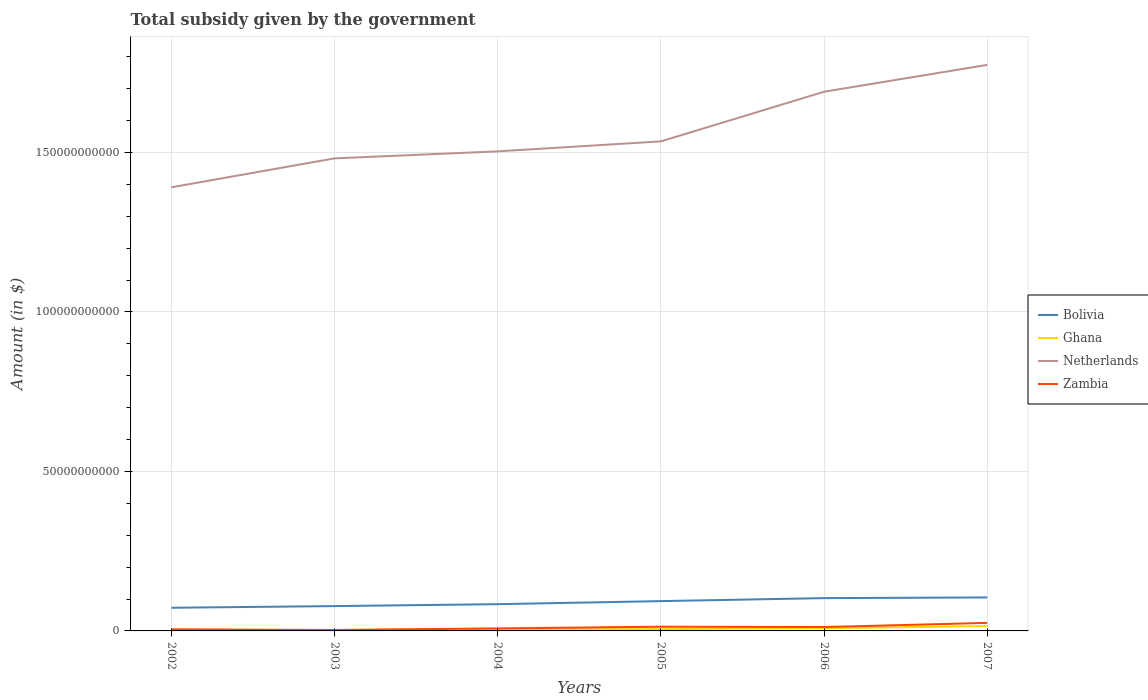Across all years, what is the maximum total revenue collected by the government in Zambia?
Offer a terse response. 2.97e+08. In which year was the total revenue collected by the government in Bolivia maximum?
Keep it short and to the point. 2002. What is the total total revenue collected by the government in Bolivia in the graph?
Provide a succinct answer. -3.02e+09. What is the difference between the highest and the second highest total revenue collected by the government in Netherlands?
Offer a very short reply. 3.84e+1. What is the difference between the highest and the lowest total revenue collected by the government in Ghana?
Ensure brevity in your answer.  2. What is the difference between two consecutive major ticks on the Y-axis?
Make the answer very short. 5.00e+1. Does the graph contain any zero values?
Your response must be concise. No. Where does the legend appear in the graph?
Provide a succinct answer. Center right. How many legend labels are there?
Your answer should be very brief. 4. How are the legend labels stacked?
Your answer should be very brief. Vertical. What is the title of the graph?
Provide a short and direct response. Total subsidy given by the government. What is the label or title of the X-axis?
Offer a terse response. Years. What is the label or title of the Y-axis?
Offer a very short reply. Amount (in $). What is the Amount (in $) of Bolivia in 2002?
Your answer should be compact. 7.27e+09. What is the Amount (in $) of Ghana in 2002?
Offer a terse response. 3.86e+07. What is the Amount (in $) of Netherlands in 2002?
Your answer should be very brief. 1.39e+11. What is the Amount (in $) in Zambia in 2002?
Your answer should be compact. 4.99e+08. What is the Amount (in $) of Bolivia in 2003?
Keep it short and to the point. 7.78e+09. What is the Amount (in $) of Ghana in 2003?
Give a very brief answer. 2.80e+08. What is the Amount (in $) of Netherlands in 2003?
Provide a short and direct response. 1.48e+11. What is the Amount (in $) of Zambia in 2003?
Make the answer very short. 2.97e+08. What is the Amount (in $) of Bolivia in 2004?
Provide a short and direct response. 8.39e+09. What is the Amount (in $) of Ghana in 2004?
Keep it short and to the point. 5.37e+08. What is the Amount (in $) of Netherlands in 2004?
Make the answer very short. 1.50e+11. What is the Amount (in $) of Zambia in 2004?
Your response must be concise. 7.88e+08. What is the Amount (in $) in Bolivia in 2005?
Ensure brevity in your answer.  9.35e+09. What is the Amount (in $) of Ghana in 2005?
Provide a succinct answer. 5.64e+08. What is the Amount (in $) in Netherlands in 2005?
Keep it short and to the point. 1.53e+11. What is the Amount (in $) in Zambia in 2005?
Keep it short and to the point. 1.32e+09. What is the Amount (in $) in Bolivia in 2006?
Provide a short and direct response. 1.03e+1. What is the Amount (in $) of Ghana in 2006?
Keep it short and to the point. 8.37e+08. What is the Amount (in $) of Netherlands in 2006?
Your response must be concise. 1.69e+11. What is the Amount (in $) in Zambia in 2006?
Your answer should be very brief. 1.21e+09. What is the Amount (in $) of Bolivia in 2007?
Provide a short and direct response. 1.05e+1. What is the Amount (in $) of Ghana in 2007?
Give a very brief answer. 1.53e+09. What is the Amount (in $) of Netherlands in 2007?
Your answer should be compact. 1.77e+11. What is the Amount (in $) of Zambia in 2007?
Your response must be concise. 2.52e+09. Across all years, what is the maximum Amount (in $) in Bolivia?
Keep it short and to the point. 1.05e+1. Across all years, what is the maximum Amount (in $) of Ghana?
Provide a short and direct response. 1.53e+09. Across all years, what is the maximum Amount (in $) of Netherlands?
Give a very brief answer. 1.77e+11. Across all years, what is the maximum Amount (in $) in Zambia?
Offer a terse response. 2.52e+09. Across all years, what is the minimum Amount (in $) in Bolivia?
Offer a very short reply. 7.27e+09. Across all years, what is the minimum Amount (in $) in Ghana?
Make the answer very short. 3.86e+07. Across all years, what is the minimum Amount (in $) in Netherlands?
Make the answer very short. 1.39e+11. Across all years, what is the minimum Amount (in $) in Zambia?
Ensure brevity in your answer.  2.97e+08. What is the total Amount (in $) in Bolivia in the graph?
Your answer should be compact. 5.36e+1. What is the total Amount (in $) in Ghana in the graph?
Your answer should be compact. 3.78e+09. What is the total Amount (in $) of Netherlands in the graph?
Ensure brevity in your answer.  9.37e+11. What is the total Amount (in $) in Zambia in the graph?
Make the answer very short. 6.64e+09. What is the difference between the Amount (in $) of Bolivia in 2002 and that in 2003?
Your answer should be very brief. -5.16e+08. What is the difference between the Amount (in $) of Ghana in 2002 and that in 2003?
Keep it short and to the point. -2.42e+08. What is the difference between the Amount (in $) in Netherlands in 2002 and that in 2003?
Offer a very short reply. -9.08e+09. What is the difference between the Amount (in $) in Zambia in 2002 and that in 2003?
Give a very brief answer. 2.02e+08. What is the difference between the Amount (in $) of Bolivia in 2002 and that in 2004?
Your answer should be compact. -1.12e+09. What is the difference between the Amount (in $) of Ghana in 2002 and that in 2004?
Provide a succinct answer. -4.98e+08. What is the difference between the Amount (in $) of Netherlands in 2002 and that in 2004?
Offer a very short reply. -1.13e+1. What is the difference between the Amount (in $) of Zambia in 2002 and that in 2004?
Provide a succinct answer. -2.89e+08. What is the difference between the Amount (in $) of Bolivia in 2002 and that in 2005?
Ensure brevity in your answer.  -2.08e+09. What is the difference between the Amount (in $) of Ghana in 2002 and that in 2005?
Provide a short and direct response. -5.25e+08. What is the difference between the Amount (in $) in Netherlands in 2002 and that in 2005?
Your response must be concise. -1.44e+1. What is the difference between the Amount (in $) of Zambia in 2002 and that in 2005?
Offer a very short reply. -8.23e+08. What is the difference between the Amount (in $) of Bolivia in 2002 and that in 2006?
Ensure brevity in your answer.  -3.02e+09. What is the difference between the Amount (in $) of Ghana in 2002 and that in 2006?
Provide a short and direct response. -7.98e+08. What is the difference between the Amount (in $) of Netherlands in 2002 and that in 2006?
Give a very brief answer. -3.00e+1. What is the difference between the Amount (in $) of Zambia in 2002 and that in 2006?
Provide a succinct answer. -7.11e+08. What is the difference between the Amount (in $) of Bolivia in 2002 and that in 2007?
Your answer should be compact. -3.23e+09. What is the difference between the Amount (in $) in Ghana in 2002 and that in 2007?
Offer a very short reply. -1.49e+09. What is the difference between the Amount (in $) of Netherlands in 2002 and that in 2007?
Give a very brief answer. -3.84e+1. What is the difference between the Amount (in $) in Zambia in 2002 and that in 2007?
Give a very brief answer. -2.02e+09. What is the difference between the Amount (in $) in Bolivia in 2003 and that in 2004?
Give a very brief answer. -6.06e+08. What is the difference between the Amount (in $) in Ghana in 2003 and that in 2004?
Provide a succinct answer. -2.57e+08. What is the difference between the Amount (in $) of Netherlands in 2003 and that in 2004?
Your answer should be compact. -2.20e+09. What is the difference between the Amount (in $) of Zambia in 2003 and that in 2004?
Give a very brief answer. -4.91e+08. What is the difference between the Amount (in $) in Bolivia in 2003 and that in 2005?
Give a very brief answer. -1.56e+09. What is the difference between the Amount (in $) of Ghana in 2003 and that in 2005?
Make the answer very short. -2.84e+08. What is the difference between the Amount (in $) in Netherlands in 2003 and that in 2005?
Make the answer very short. -5.32e+09. What is the difference between the Amount (in $) in Zambia in 2003 and that in 2005?
Offer a very short reply. -1.02e+09. What is the difference between the Amount (in $) of Bolivia in 2003 and that in 2006?
Your response must be concise. -2.50e+09. What is the difference between the Amount (in $) of Ghana in 2003 and that in 2006?
Keep it short and to the point. -5.57e+08. What is the difference between the Amount (in $) of Netherlands in 2003 and that in 2006?
Keep it short and to the point. -2.09e+1. What is the difference between the Amount (in $) in Zambia in 2003 and that in 2006?
Your response must be concise. -9.13e+08. What is the difference between the Amount (in $) of Bolivia in 2003 and that in 2007?
Provide a succinct answer. -2.71e+09. What is the difference between the Amount (in $) in Ghana in 2003 and that in 2007?
Ensure brevity in your answer.  -1.25e+09. What is the difference between the Amount (in $) in Netherlands in 2003 and that in 2007?
Provide a short and direct response. -2.93e+1. What is the difference between the Amount (in $) of Zambia in 2003 and that in 2007?
Your answer should be very brief. -2.23e+09. What is the difference between the Amount (in $) in Bolivia in 2004 and that in 2005?
Offer a very short reply. -9.58e+08. What is the difference between the Amount (in $) of Ghana in 2004 and that in 2005?
Ensure brevity in your answer.  -2.71e+07. What is the difference between the Amount (in $) in Netherlands in 2004 and that in 2005?
Your answer should be compact. -3.13e+09. What is the difference between the Amount (in $) of Zambia in 2004 and that in 2005?
Make the answer very short. -5.34e+08. What is the difference between the Amount (in $) of Bolivia in 2004 and that in 2006?
Make the answer very short. -1.90e+09. What is the difference between the Amount (in $) of Ghana in 2004 and that in 2006?
Ensure brevity in your answer.  -3.00e+08. What is the difference between the Amount (in $) of Netherlands in 2004 and that in 2006?
Keep it short and to the point. -1.87e+1. What is the difference between the Amount (in $) of Zambia in 2004 and that in 2006?
Offer a terse response. -4.23e+08. What is the difference between the Amount (in $) in Bolivia in 2004 and that in 2007?
Your response must be concise. -2.11e+09. What is the difference between the Amount (in $) of Ghana in 2004 and that in 2007?
Provide a succinct answer. -9.92e+08. What is the difference between the Amount (in $) in Netherlands in 2004 and that in 2007?
Offer a terse response. -2.71e+1. What is the difference between the Amount (in $) in Zambia in 2004 and that in 2007?
Your response must be concise. -1.73e+09. What is the difference between the Amount (in $) in Bolivia in 2005 and that in 2006?
Your answer should be compact. -9.38e+08. What is the difference between the Amount (in $) in Ghana in 2005 and that in 2006?
Provide a succinct answer. -2.73e+08. What is the difference between the Amount (in $) in Netherlands in 2005 and that in 2006?
Offer a terse response. -1.56e+1. What is the difference between the Amount (in $) of Zambia in 2005 and that in 2006?
Your answer should be compact. 1.12e+08. What is the difference between the Amount (in $) of Bolivia in 2005 and that in 2007?
Offer a very short reply. -1.15e+09. What is the difference between the Amount (in $) of Ghana in 2005 and that in 2007?
Give a very brief answer. -9.65e+08. What is the difference between the Amount (in $) in Netherlands in 2005 and that in 2007?
Ensure brevity in your answer.  -2.40e+1. What is the difference between the Amount (in $) of Zambia in 2005 and that in 2007?
Provide a succinct answer. -1.20e+09. What is the difference between the Amount (in $) in Bolivia in 2006 and that in 2007?
Provide a short and direct response. -2.12e+08. What is the difference between the Amount (in $) of Ghana in 2006 and that in 2007?
Provide a short and direct response. -6.92e+08. What is the difference between the Amount (in $) in Netherlands in 2006 and that in 2007?
Keep it short and to the point. -8.42e+09. What is the difference between the Amount (in $) in Zambia in 2006 and that in 2007?
Your answer should be compact. -1.31e+09. What is the difference between the Amount (in $) in Bolivia in 2002 and the Amount (in $) in Ghana in 2003?
Offer a terse response. 6.99e+09. What is the difference between the Amount (in $) in Bolivia in 2002 and the Amount (in $) in Netherlands in 2003?
Offer a very short reply. -1.41e+11. What is the difference between the Amount (in $) of Bolivia in 2002 and the Amount (in $) of Zambia in 2003?
Give a very brief answer. 6.97e+09. What is the difference between the Amount (in $) in Ghana in 2002 and the Amount (in $) in Netherlands in 2003?
Ensure brevity in your answer.  -1.48e+11. What is the difference between the Amount (in $) of Ghana in 2002 and the Amount (in $) of Zambia in 2003?
Your response must be concise. -2.59e+08. What is the difference between the Amount (in $) in Netherlands in 2002 and the Amount (in $) in Zambia in 2003?
Your response must be concise. 1.39e+11. What is the difference between the Amount (in $) in Bolivia in 2002 and the Amount (in $) in Ghana in 2004?
Your answer should be compact. 6.73e+09. What is the difference between the Amount (in $) of Bolivia in 2002 and the Amount (in $) of Netherlands in 2004?
Keep it short and to the point. -1.43e+11. What is the difference between the Amount (in $) of Bolivia in 2002 and the Amount (in $) of Zambia in 2004?
Keep it short and to the point. 6.48e+09. What is the difference between the Amount (in $) of Ghana in 2002 and the Amount (in $) of Netherlands in 2004?
Offer a terse response. -1.50e+11. What is the difference between the Amount (in $) in Ghana in 2002 and the Amount (in $) in Zambia in 2004?
Your answer should be compact. -7.49e+08. What is the difference between the Amount (in $) of Netherlands in 2002 and the Amount (in $) of Zambia in 2004?
Keep it short and to the point. 1.38e+11. What is the difference between the Amount (in $) of Bolivia in 2002 and the Amount (in $) of Ghana in 2005?
Offer a very short reply. 6.70e+09. What is the difference between the Amount (in $) in Bolivia in 2002 and the Amount (in $) in Netherlands in 2005?
Give a very brief answer. -1.46e+11. What is the difference between the Amount (in $) in Bolivia in 2002 and the Amount (in $) in Zambia in 2005?
Provide a succinct answer. 5.94e+09. What is the difference between the Amount (in $) in Ghana in 2002 and the Amount (in $) in Netherlands in 2005?
Make the answer very short. -1.53e+11. What is the difference between the Amount (in $) in Ghana in 2002 and the Amount (in $) in Zambia in 2005?
Make the answer very short. -1.28e+09. What is the difference between the Amount (in $) in Netherlands in 2002 and the Amount (in $) in Zambia in 2005?
Make the answer very short. 1.38e+11. What is the difference between the Amount (in $) of Bolivia in 2002 and the Amount (in $) of Ghana in 2006?
Offer a very short reply. 6.43e+09. What is the difference between the Amount (in $) in Bolivia in 2002 and the Amount (in $) in Netherlands in 2006?
Offer a very short reply. -1.62e+11. What is the difference between the Amount (in $) of Bolivia in 2002 and the Amount (in $) of Zambia in 2006?
Offer a very short reply. 6.06e+09. What is the difference between the Amount (in $) in Ghana in 2002 and the Amount (in $) in Netherlands in 2006?
Offer a terse response. -1.69e+11. What is the difference between the Amount (in $) of Ghana in 2002 and the Amount (in $) of Zambia in 2006?
Ensure brevity in your answer.  -1.17e+09. What is the difference between the Amount (in $) of Netherlands in 2002 and the Amount (in $) of Zambia in 2006?
Offer a terse response. 1.38e+11. What is the difference between the Amount (in $) in Bolivia in 2002 and the Amount (in $) in Ghana in 2007?
Your answer should be very brief. 5.74e+09. What is the difference between the Amount (in $) of Bolivia in 2002 and the Amount (in $) of Netherlands in 2007?
Give a very brief answer. -1.70e+11. What is the difference between the Amount (in $) of Bolivia in 2002 and the Amount (in $) of Zambia in 2007?
Ensure brevity in your answer.  4.74e+09. What is the difference between the Amount (in $) of Ghana in 2002 and the Amount (in $) of Netherlands in 2007?
Provide a succinct answer. -1.77e+11. What is the difference between the Amount (in $) of Ghana in 2002 and the Amount (in $) of Zambia in 2007?
Your answer should be very brief. -2.48e+09. What is the difference between the Amount (in $) of Netherlands in 2002 and the Amount (in $) of Zambia in 2007?
Provide a succinct answer. 1.37e+11. What is the difference between the Amount (in $) in Bolivia in 2003 and the Amount (in $) in Ghana in 2004?
Offer a very short reply. 7.24e+09. What is the difference between the Amount (in $) in Bolivia in 2003 and the Amount (in $) in Netherlands in 2004?
Your answer should be compact. -1.43e+11. What is the difference between the Amount (in $) in Bolivia in 2003 and the Amount (in $) in Zambia in 2004?
Provide a short and direct response. 6.99e+09. What is the difference between the Amount (in $) in Ghana in 2003 and the Amount (in $) in Netherlands in 2004?
Your answer should be compact. -1.50e+11. What is the difference between the Amount (in $) of Ghana in 2003 and the Amount (in $) of Zambia in 2004?
Give a very brief answer. -5.08e+08. What is the difference between the Amount (in $) of Netherlands in 2003 and the Amount (in $) of Zambia in 2004?
Your response must be concise. 1.47e+11. What is the difference between the Amount (in $) in Bolivia in 2003 and the Amount (in $) in Ghana in 2005?
Your answer should be very brief. 7.22e+09. What is the difference between the Amount (in $) in Bolivia in 2003 and the Amount (in $) in Netherlands in 2005?
Make the answer very short. -1.46e+11. What is the difference between the Amount (in $) in Bolivia in 2003 and the Amount (in $) in Zambia in 2005?
Give a very brief answer. 6.46e+09. What is the difference between the Amount (in $) of Ghana in 2003 and the Amount (in $) of Netherlands in 2005?
Provide a short and direct response. -1.53e+11. What is the difference between the Amount (in $) of Ghana in 2003 and the Amount (in $) of Zambia in 2005?
Your answer should be compact. -1.04e+09. What is the difference between the Amount (in $) in Netherlands in 2003 and the Amount (in $) in Zambia in 2005?
Your response must be concise. 1.47e+11. What is the difference between the Amount (in $) in Bolivia in 2003 and the Amount (in $) in Ghana in 2006?
Keep it short and to the point. 6.94e+09. What is the difference between the Amount (in $) of Bolivia in 2003 and the Amount (in $) of Netherlands in 2006?
Offer a terse response. -1.61e+11. What is the difference between the Amount (in $) of Bolivia in 2003 and the Amount (in $) of Zambia in 2006?
Provide a succinct answer. 6.57e+09. What is the difference between the Amount (in $) of Ghana in 2003 and the Amount (in $) of Netherlands in 2006?
Keep it short and to the point. -1.69e+11. What is the difference between the Amount (in $) of Ghana in 2003 and the Amount (in $) of Zambia in 2006?
Give a very brief answer. -9.31e+08. What is the difference between the Amount (in $) of Netherlands in 2003 and the Amount (in $) of Zambia in 2006?
Provide a short and direct response. 1.47e+11. What is the difference between the Amount (in $) in Bolivia in 2003 and the Amount (in $) in Ghana in 2007?
Ensure brevity in your answer.  6.25e+09. What is the difference between the Amount (in $) of Bolivia in 2003 and the Amount (in $) of Netherlands in 2007?
Your response must be concise. -1.70e+11. What is the difference between the Amount (in $) in Bolivia in 2003 and the Amount (in $) in Zambia in 2007?
Ensure brevity in your answer.  5.26e+09. What is the difference between the Amount (in $) of Ghana in 2003 and the Amount (in $) of Netherlands in 2007?
Make the answer very short. -1.77e+11. What is the difference between the Amount (in $) in Ghana in 2003 and the Amount (in $) in Zambia in 2007?
Your response must be concise. -2.24e+09. What is the difference between the Amount (in $) in Netherlands in 2003 and the Amount (in $) in Zambia in 2007?
Your response must be concise. 1.46e+11. What is the difference between the Amount (in $) of Bolivia in 2004 and the Amount (in $) of Ghana in 2005?
Provide a succinct answer. 7.82e+09. What is the difference between the Amount (in $) of Bolivia in 2004 and the Amount (in $) of Netherlands in 2005?
Your answer should be compact. -1.45e+11. What is the difference between the Amount (in $) of Bolivia in 2004 and the Amount (in $) of Zambia in 2005?
Your answer should be very brief. 7.07e+09. What is the difference between the Amount (in $) of Ghana in 2004 and the Amount (in $) of Netherlands in 2005?
Provide a short and direct response. -1.53e+11. What is the difference between the Amount (in $) of Ghana in 2004 and the Amount (in $) of Zambia in 2005?
Ensure brevity in your answer.  -7.85e+08. What is the difference between the Amount (in $) of Netherlands in 2004 and the Amount (in $) of Zambia in 2005?
Provide a short and direct response. 1.49e+11. What is the difference between the Amount (in $) in Bolivia in 2004 and the Amount (in $) in Ghana in 2006?
Your answer should be very brief. 7.55e+09. What is the difference between the Amount (in $) of Bolivia in 2004 and the Amount (in $) of Netherlands in 2006?
Your answer should be compact. -1.61e+11. What is the difference between the Amount (in $) of Bolivia in 2004 and the Amount (in $) of Zambia in 2006?
Offer a terse response. 7.18e+09. What is the difference between the Amount (in $) of Ghana in 2004 and the Amount (in $) of Netherlands in 2006?
Keep it short and to the point. -1.68e+11. What is the difference between the Amount (in $) in Ghana in 2004 and the Amount (in $) in Zambia in 2006?
Provide a succinct answer. -6.74e+08. What is the difference between the Amount (in $) in Netherlands in 2004 and the Amount (in $) in Zambia in 2006?
Give a very brief answer. 1.49e+11. What is the difference between the Amount (in $) of Bolivia in 2004 and the Amount (in $) of Ghana in 2007?
Ensure brevity in your answer.  6.86e+09. What is the difference between the Amount (in $) in Bolivia in 2004 and the Amount (in $) in Netherlands in 2007?
Provide a succinct answer. -1.69e+11. What is the difference between the Amount (in $) in Bolivia in 2004 and the Amount (in $) in Zambia in 2007?
Offer a very short reply. 5.86e+09. What is the difference between the Amount (in $) in Ghana in 2004 and the Amount (in $) in Netherlands in 2007?
Provide a short and direct response. -1.77e+11. What is the difference between the Amount (in $) of Ghana in 2004 and the Amount (in $) of Zambia in 2007?
Offer a terse response. -1.99e+09. What is the difference between the Amount (in $) in Netherlands in 2004 and the Amount (in $) in Zambia in 2007?
Give a very brief answer. 1.48e+11. What is the difference between the Amount (in $) of Bolivia in 2005 and the Amount (in $) of Ghana in 2006?
Keep it short and to the point. 8.51e+09. What is the difference between the Amount (in $) in Bolivia in 2005 and the Amount (in $) in Netherlands in 2006?
Make the answer very short. -1.60e+11. What is the difference between the Amount (in $) in Bolivia in 2005 and the Amount (in $) in Zambia in 2006?
Your response must be concise. 8.13e+09. What is the difference between the Amount (in $) of Ghana in 2005 and the Amount (in $) of Netherlands in 2006?
Keep it short and to the point. -1.68e+11. What is the difference between the Amount (in $) of Ghana in 2005 and the Amount (in $) of Zambia in 2006?
Provide a succinct answer. -6.47e+08. What is the difference between the Amount (in $) in Netherlands in 2005 and the Amount (in $) in Zambia in 2006?
Provide a succinct answer. 1.52e+11. What is the difference between the Amount (in $) of Bolivia in 2005 and the Amount (in $) of Ghana in 2007?
Give a very brief answer. 7.82e+09. What is the difference between the Amount (in $) of Bolivia in 2005 and the Amount (in $) of Netherlands in 2007?
Keep it short and to the point. -1.68e+11. What is the difference between the Amount (in $) in Bolivia in 2005 and the Amount (in $) in Zambia in 2007?
Ensure brevity in your answer.  6.82e+09. What is the difference between the Amount (in $) in Ghana in 2005 and the Amount (in $) in Netherlands in 2007?
Your response must be concise. -1.77e+11. What is the difference between the Amount (in $) in Ghana in 2005 and the Amount (in $) in Zambia in 2007?
Make the answer very short. -1.96e+09. What is the difference between the Amount (in $) of Netherlands in 2005 and the Amount (in $) of Zambia in 2007?
Offer a terse response. 1.51e+11. What is the difference between the Amount (in $) of Bolivia in 2006 and the Amount (in $) of Ghana in 2007?
Give a very brief answer. 8.75e+09. What is the difference between the Amount (in $) of Bolivia in 2006 and the Amount (in $) of Netherlands in 2007?
Ensure brevity in your answer.  -1.67e+11. What is the difference between the Amount (in $) of Bolivia in 2006 and the Amount (in $) of Zambia in 2007?
Make the answer very short. 7.76e+09. What is the difference between the Amount (in $) in Ghana in 2006 and the Amount (in $) in Netherlands in 2007?
Your answer should be compact. -1.77e+11. What is the difference between the Amount (in $) in Ghana in 2006 and the Amount (in $) in Zambia in 2007?
Keep it short and to the point. -1.69e+09. What is the difference between the Amount (in $) of Netherlands in 2006 and the Amount (in $) of Zambia in 2007?
Provide a short and direct response. 1.67e+11. What is the average Amount (in $) of Bolivia per year?
Keep it short and to the point. 8.93e+09. What is the average Amount (in $) of Ghana per year?
Offer a terse response. 6.31e+08. What is the average Amount (in $) of Netherlands per year?
Provide a succinct answer. 1.56e+11. What is the average Amount (in $) of Zambia per year?
Offer a terse response. 1.11e+09. In the year 2002, what is the difference between the Amount (in $) of Bolivia and Amount (in $) of Ghana?
Offer a very short reply. 7.23e+09. In the year 2002, what is the difference between the Amount (in $) of Bolivia and Amount (in $) of Netherlands?
Offer a very short reply. -1.32e+11. In the year 2002, what is the difference between the Amount (in $) in Bolivia and Amount (in $) in Zambia?
Make the answer very short. 6.77e+09. In the year 2002, what is the difference between the Amount (in $) in Ghana and Amount (in $) in Netherlands?
Your answer should be very brief. -1.39e+11. In the year 2002, what is the difference between the Amount (in $) in Ghana and Amount (in $) in Zambia?
Your response must be concise. -4.61e+08. In the year 2002, what is the difference between the Amount (in $) in Netherlands and Amount (in $) in Zambia?
Make the answer very short. 1.39e+11. In the year 2003, what is the difference between the Amount (in $) in Bolivia and Amount (in $) in Ghana?
Keep it short and to the point. 7.50e+09. In the year 2003, what is the difference between the Amount (in $) in Bolivia and Amount (in $) in Netherlands?
Provide a short and direct response. -1.40e+11. In the year 2003, what is the difference between the Amount (in $) in Bolivia and Amount (in $) in Zambia?
Provide a succinct answer. 7.48e+09. In the year 2003, what is the difference between the Amount (in $) in Ghana and Amount (in $) in Netherlands?
Ensure brevity in your answer.  -1.48e+11. In the year 2003, what is the difference between the Amount (in $) of Ghana and Amount (in $) of Zambia?
Ensure brevity in your answer.  -1.72e+07. In the year 2003, what is the difference between the Amount (in $) in Netherlands and Amount (in $) in Zambia?
Offer a very short reply. 1.48e+11. In the year 2004, what is the difference between the Amount (in $) in Bolivia and Amount (in $) in Ghana?
Give a very brief answer. 7.85e+09. In the year 2004, what is the difference between the Amount (in $) in Bolivia and Amount (in $) in Netherlands?
Provide a succinct answer. -1.42e+11. In the year 2004, what is the difference between the Amount (in $) of Bolivia and Amount (in $) of Zambia?
Your answer should be compact. 7.60e+09. In the year 2004, what is the difference between the Amount (in $) in Ghana and Amount (in $) in Netherlands?
Your answer should be compact. -1.50e+11. In the year 2004, what is the difference between the Amount (in $) in Ghana and Amount (in $) in Zambia?
Offer a very short reply. -2.51e+08. In the year 2004, what is the difference between the Amount (in $) in Netherlands and Amount (in $) in Zambia?
Offer a very short reply. 1.50e+11. In the year 2005, what is the difference between the Amount (in $) of Bolivia and Amount (in $) of Ghana?
Your response must be concise. 8.78e+09. In the year 2005, what is the difference between the Amount (in $) in Bolivia and Amount (in $) in Netherlands?
Provide a succinct answer. -1.44e+11. In the year 2005, what is the difference between the Amount (in $) in Bolivia and Amount (in $) in Zambia?
Offer a very short reply. 8.02e+09. In the year 2005, what is the difference between the Amount (in $) in Ghana and Amount (in $) in Netherlands?
Your answer should be very brief. -1.53e+11. In the year 2005, what is the difference between the Amount (in $) in Ghana and Amount (in $) in Zambia?
Make the answer very short. -7.58e+08. In the year 2005, what is the difference between the Amount (in $) in Netherlands and Amount (in $) in Zambia?
Give a very brief answer. 1.52e+11. In the year 2006, what is the difference between the Amount (in $) of Bolivia and Amount (in $) of Ghana?
Offer a very short reply. 9.45e+09. In the year 2006, what is the difference between the Amount (in $) in Bolivia and Amount (in $) in Netherlands?
Your answer should be very brief. -1.59e+11. In the year 2006, what is the difference between the Amount (in $) in Bolivia and Amount (in $) in Zambia?
Ensure brevity in your answer.  9.07e+09. In the year 2006, what is the difference between the Amount (in $) in Ghana and Amount (in $) in Netherlands?
Make the answer very short. -1.68e+11. In the year 2006, what is the difference between the Amount (in $) of Ghana and Amount (in $) of Zambia?
Keep it short and to the point. -3.74e+08. In the year 2006, what is the difference between the Amount (in $) of Netherlands and Amount (in $) of Zambia?
Keep it short and to the point. 1.68e+11. In the year 2007, what is the difference between the Amount (in $) in Bolivia and Amount (in $) in Ghana?
Give a very brief answer. 8.97e+09. In the year 2007, what is the difference between the Amount (in $) of Bolivia and Amount (in $) of Netherlands?
Ensure brevity in your answer.  -1.67e+11. In the year 2007, what is the difference between the Amount (in $) of Bolivia and Amount (in $) of Zambia?
Give a very brief answer. 7.97e+09. In the year 2007, what is the difference between the Amount (in $) in Ghana and Amount (in $) in Netherlands?
Keep it short and to the point. -1.76e+11. In the year 2007, what is the difference between the Amount (in $) in Ghana and Amount (in $) in Zambia?
Make the answer very short. -9.93e+08. In the year 2007, what is the difference between the Amount (in $) of Netherlands and Amount (in $) of Zambia?
Provide a short and direct response. 1.75e+11. What is the ratio of the Amount (in $) of Bolivia in 2002 to that in 2003?
Offer a terse response. 0.93. What is the ratio of the Amount (in $) of Ghana in 2002 to that in 2003?
Ensure brevity in your answer.  0.14. What is the ratio of the Amount (in $) in Netherlands in 2002 to that in 2003?
Provide a succinct answer. 0.94. What is the ratio of the Amount (in $) in Zambia in 2002 to that in 2003?
Offer a very short reply. 1.68. What is the ratio of the Amount (in $) in Bolivia in 2002 to that in 2004?
Keep it short and to the point. 0.87. What is the ratio of the Amount (in $) in Ghana in 2002 to that in 2004?
Provide a succinct answer. 0.07. What is the ratio of the Amount (in $) of Netherlands in 2002 to that in 2004?
Your answer should be compact. 0.93. What is the ratio of the Amount (in $) of Zambia in 2002 to that in 2004?
Keep it short and to the point. 0.63. What is the ratio of the Amount (in $) of Bolivia in 2002 to that in 2005?
Offer a terse response. 0.78. What is the ratio of the Amount (in $) in Ghana in 2002 to that in 2005?
Keep it short and to the point. 0.07. What is the ratio of the Amount (in $) in Netherlands in 2002 to that in 2005?
Your answer should be very brief. 0.91. What is the ratio of the Amount (in $) in Zambia in 2002 to that in 2005?
Keep it short and to the point. 0.38. What is the ratio of the Amount (in $) in Bolivia in 2002 to that in 2006?
Keep it short and to the point. 0.71. What is the ratio of the Amount (in $) of Ghana in 2002 to that in 2006?
Provide a short and direct response. 0.05. What is the ratio of the Amount (in $) in Netherlands in 2002 to that in 2006?
Your answer should be compact. 0.82. What is the ratio of the Amount (in $) of Zambia in 2002 to that in 2006?
Ensure brevity in your answer.  0.41. What is the ratio of the Amount (in $) of Bolivia in 2002 to that in 2007?
Provide a succinct answer. 0.69. What is the ratio of the Amount (in $) of Ghana in 2002 to that in 2007?
Offer a terse response. 0.03. What is the ratio of the Amount (in $) in Netherlands in 2002 to that in 2007?
Provide a succinct answer. 0.78. What is the ratio of the Amount (in $) of Zambia in 2002 to that in 2007?
Keep it short and to the point. 0.2. What is the ratio of the Amount (in $) in Bolivia in 2003 to that in 2004?
Offer a very short reply. 0.93. What is the ratio of the Amount (in $) of Ghana in 2003 to that in 2004?
Provide a succinct answer. 0.52. What is the ratio of the Amount (in $) of Netherlands in 2003 to that in 2004?
Your response must be concise. 0.99. What is the ratio of the Amount (in $) in Zambia in 2003 to that in 2004?
Keep it short and to the point. 0.38. What is the ratio of the Amount (in $) of Bolivia in 2003 to that in 2005?
Make the answer very short. 0.83. What is the ratio of the Amount (in $) in Ghana in 2003 to that in 2005?
Ensure brevity in your answer.  0.5. What is the ratio of the Amount (in $) in Netherlands in 2003 to that in 2005?
Give a very brief answer. 0.97. What is the ratio of the Amount (in $) in Zambia in 2003 to that in 2005?
Give a very brief answer. 0.22. What is the ratio of the Amount (in $) of Bolivia in 2003 to that in 2006?
Provide a short and direct response. 0.76. What is the ratio of the Amount (in $) of Ghana in 2003 to that in 2006?
Your answer should be very brief. 0.33. What is the ratio of the Amount (in $) of Netherlands in 2003 to that in 2006?
Your answer should be compact. 0.88. What is the ratio of the Amount (in $) in Zambia in 2003 to that in 2006?
Provide a succinct answer. 0.25. What is the ratio of the Amount (in $) of Bolivia in 2003 to that in 2007?
Your response must be concise. 0.74. What is the ratio of the Amount (in $) of Ghana in 2003 to that in 2007?
Offer a terse response. 0.18. What is the ratio of the Amount (in $) in Netherlands in 2003 to that in 2007?
Your answer should be compact. 0.83. What is the ratio of the Amount (in $) in Zambia in 2003 to that in 2007?
Keep it short and to the point. 0.12. What is the ratio of the Amount (in $) of Bolivia in 2004 to that in 2005?
Provide a succinct answer. 0.9. What is the ratio of the Amount (in $) of Ghana in 2004 to that in 2005?
Offer a very short reply. 0.95. What is the ratio of the Amount (in $) in Netherlands in 2004 to that in 2005?
Provide a succinct answer. 0.98. What is the ratio of the Amount (in $) of Zambia in 2004 to that in 2005?
Provide a succinct answer. 0.6. What is the ratio of the Amount (in $) of Bolivia in 2004 to that in 2006?
Your response must be concise. 0.82. What is the ratio of the Amount (in $) in Ghana in 2004 to that in 2006?
Offer a very short reply. 0.64. What is the ratio of the Amount (in $) of Netherlands in 2004 to that in 2006?
Provide a short and direct response. 0.89. What is the ratio of the Amount (in $) of Zambia in 2004 to that in 2006?
Make the answer very short. 0.65. What is the ratio of the Amount (in $) of Bolivia in 2004 to that in 2007?
Offer a very short reply. 0.8. What is the ratio of the Amount (in $) of Ghana in 2004 to that in 2007?
Make the answer very short. 0.35. What is the ratio of the Amount (in $) in Netherlands in 2004 to that in 2007?
Provide a short and direct response. 0.85. What is the ratio of the Amount (in $) of Zambia in 2004 to that in 2007?
Your response must be concise. 0.31. What is the ratio of the Amount (in $) in Bolivia in 2005 to that in 2006?
Your answer should be very brief. 0.91. What is the ratio of the Amount (in $) in Ghana in 2005 to that in 2006?
Make the answer very short. 0.67. What is the ratio of the Amount (in $) of Netherlands in 2005 to that in 2006?
Offer a terse response. 0.91. What is the ratio of the Amount (in $) of Zambia in 2005 to that in 2006?
Give a very brief answer. 1.09. What is the ratio of the Amount (in $) in Bolivia in 2005 to that in 2007?
Your response must be concise. 0.89. What is the ratio of the Amount (in $) in Ghana in 2005 to that in 2007?
Offer a very short reply. 0.37. What is the ratio of the Amount (in $) of Netherlands in 2005 to that in 2007?
Provide a succinct answer. 0.86. What is the ratio of the Amount (in $) of Zambia in 2005 to that in 2007?
Offer a very short reply. 0.52. What is the ratio of the Amount (in $) in Bolivia in 2006 to that in 2007?
Make the answer very short. 0.98. What is the ratio of the Amount (in $) in Ghana in 2006 to that in 2007?
Offer a very short reply. 0.55. What is the ratio of the Amount (in $) of Netherlands in 2006 to that in 2007?
Provide a short and direct response. 0.95. What is the ratio of the Amount (in $) of Zambia in 2006 to that in 2007?
Ensure brevity in your answer.  0.48. What is the difference between the highest and the second highest Amount (in $) of Bolivia?
Ensure brevity in your answer.  2.12e+08. What is the difference between the highest and the second highest Amount (in $) of Ghana?
Your answer should be very brief. 6.92e+08. What is the difference between the highest and the second highest Amount (in $) of Netherlands?
Ensure brevity in your answer.  8.42e+09. What is the difference between the highest and the second highest Amount (in $) of Zambia?
Keep it short and to the point. 1.20e+09. What is the difference between the highest and the lowest Amount (in $) in Bolivia?
Provide a short and direct response. 3.23e+09. What is the difference between the highest and the lowest Amount (in $) of Ghana?
Ensure brevity in your answer.  1.49e+09. What is the difference between the highest and the lowest Amount (in $) of Netherlands?
Provide a succinct answer. 3.84e+1. What is the difference between the highest and the lowest Amount (in $) of Zambia?
Provide a short and direct response. 2.23e+09. 